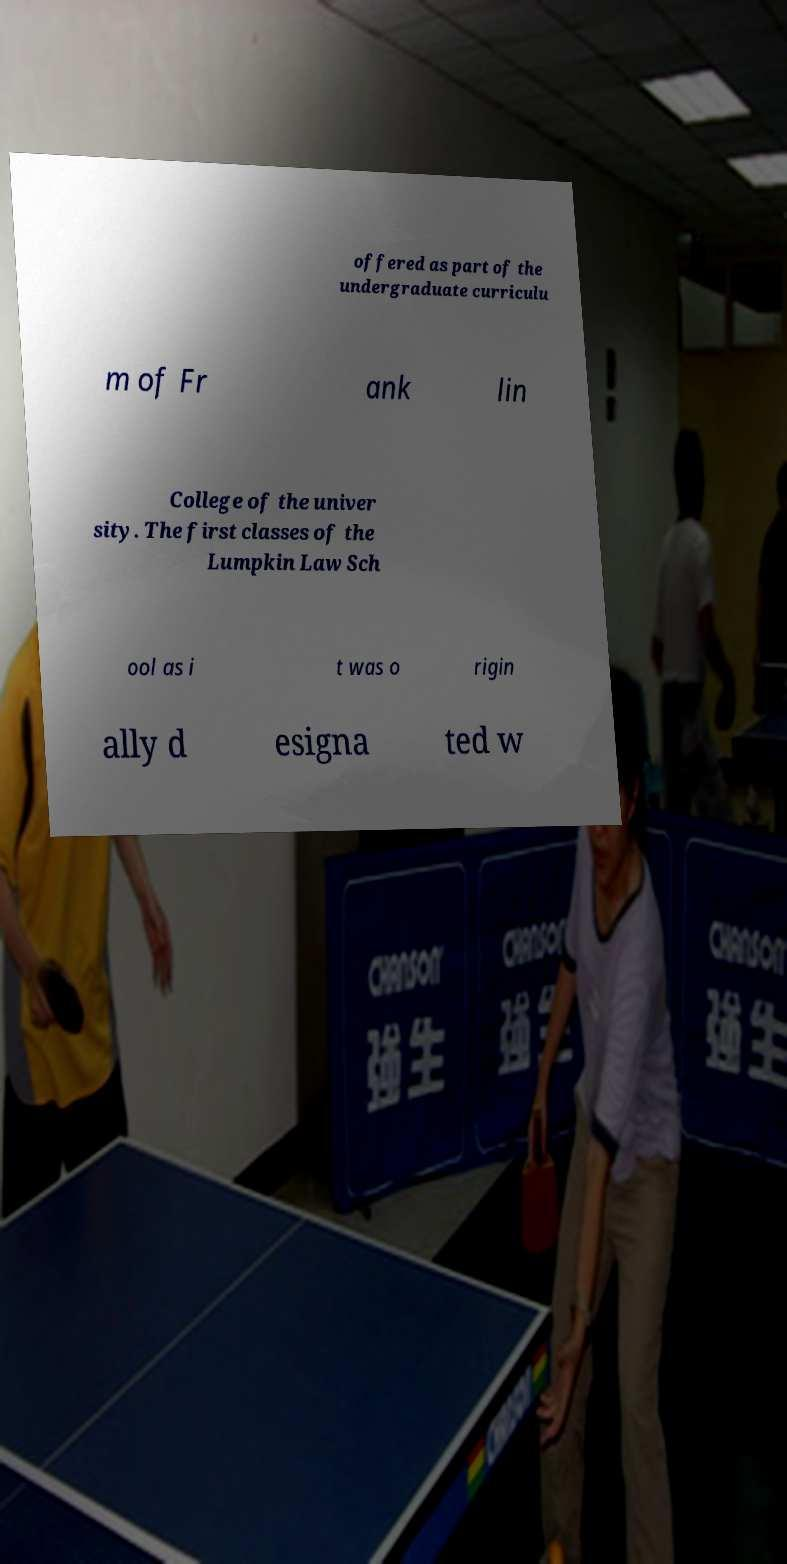Could you extract and type out the text from this image? offered as part of the undergraduate curriculu m of Fr ank lin College of the univer sity. The first classes of the Lumpkin Law Sch ool as i t was o rigin ally d esigna ted w 